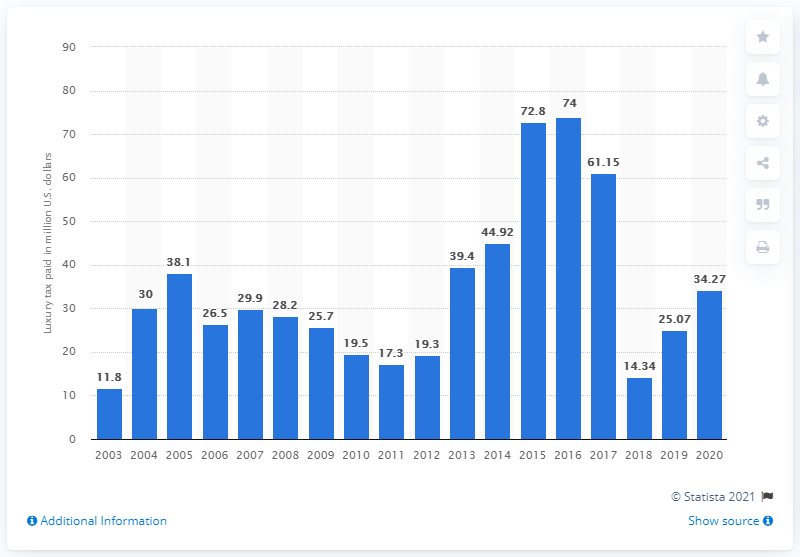Draw attention to some important aspects in this diagram. In 2020, a total of 25.07 dollars were paid in luxury taxes by Major League Baseball teams. 